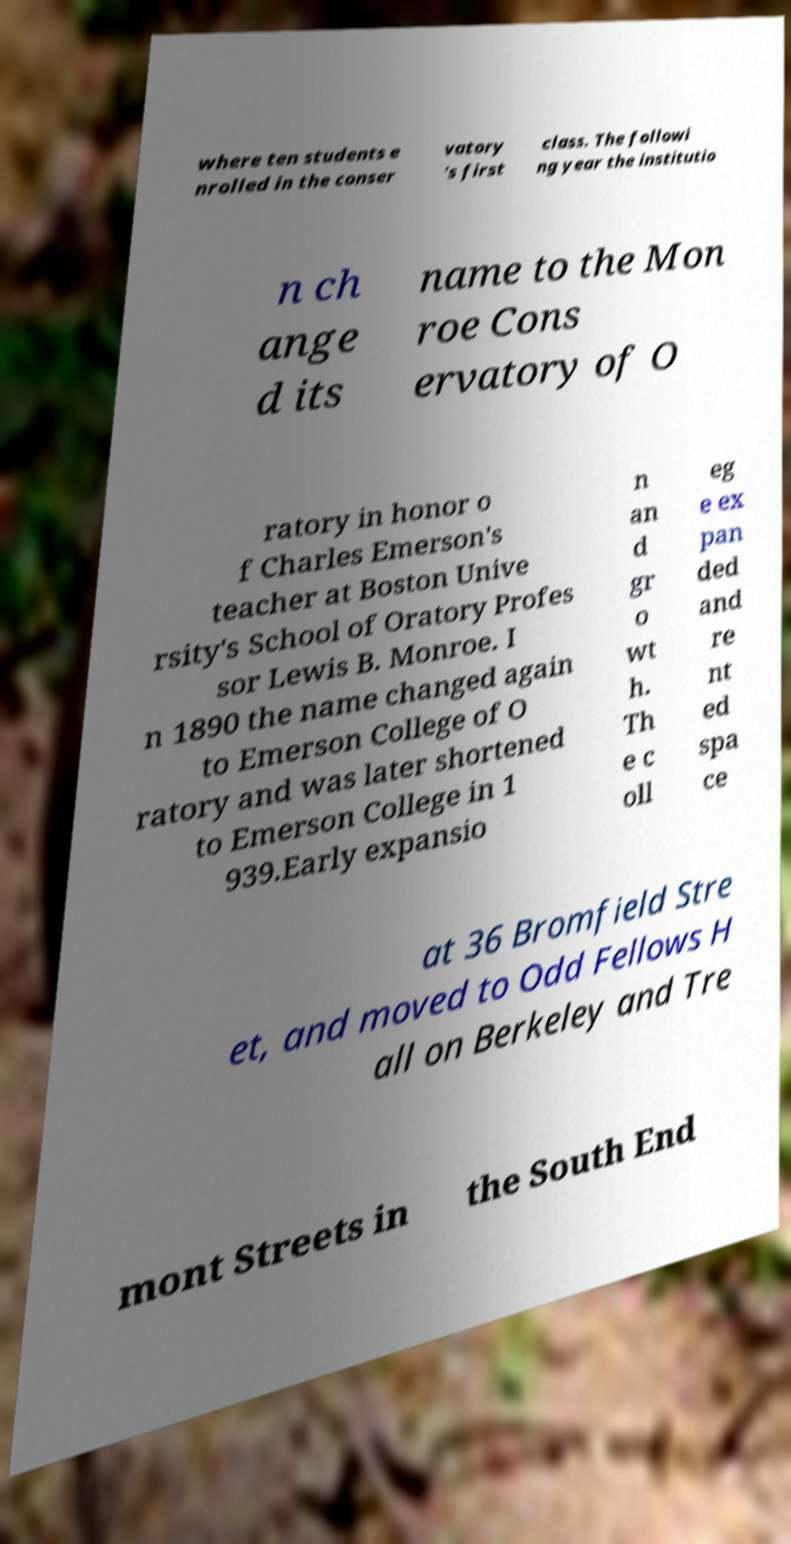I need the written content from this picture converted into text. Can you do that? where ten students e nrolled in the conser vatory 's first class. The followi ng year the institutio n ch ange d its name to the Mon roe Cons ervatory of O ratory in honor o f Charles Emerson's teacher at Boston Unive rsity's School of Oratory Profes sor Lewis B. Monroe. I n 1890 the name changed again to Emerson College of O ratory and was later shortened to Emerson College in 1 939.Early expansio n an d gr o wt h. Th e c oll eg e ex pan ded and re nt ed spa ce at 36 Bromfield Stre et, and moved to Odd Fellows H all on Berkeley and Tre mont Streets in the South End 